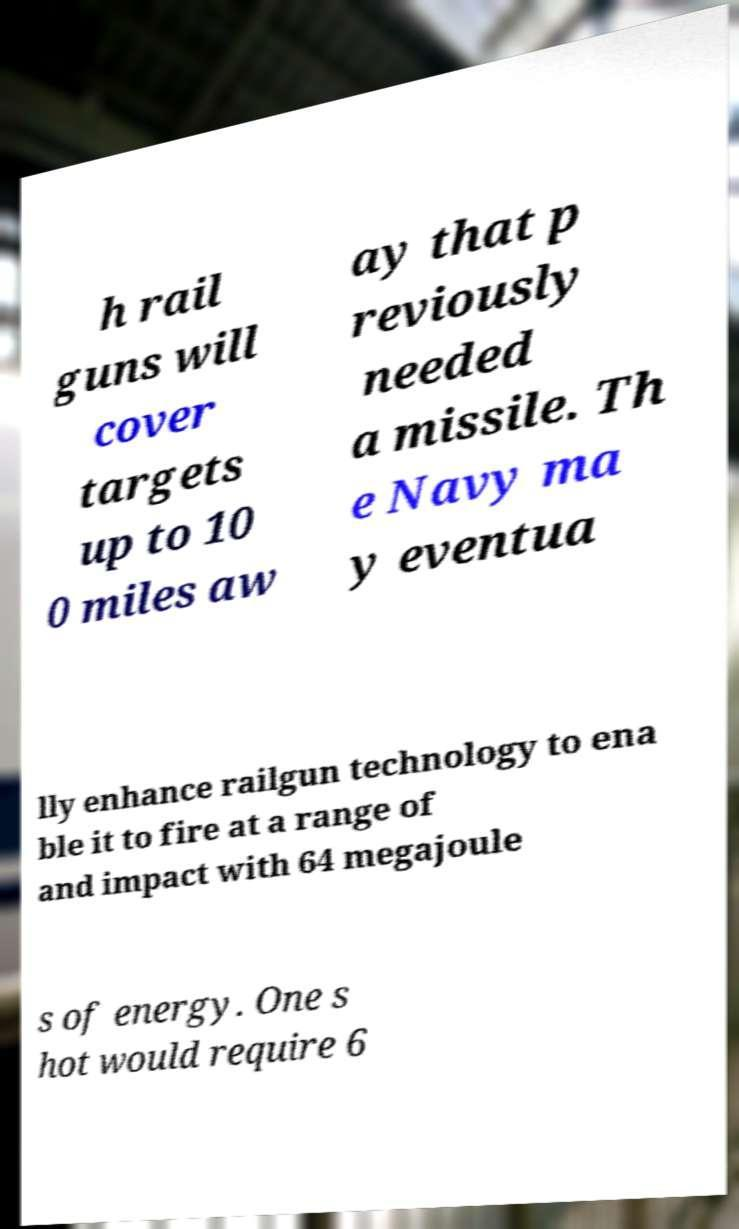I need the written content from this picture converted into text. Can you do that? h rail guns will cover targets up to 10 0 miles aw ay that p reviously needed a missile. Th e Navy ma y eventua lly enhance railgun technology to ena ble it to fire at a range of and impact with 64 megajoule s of energy. One s hot would require 6 